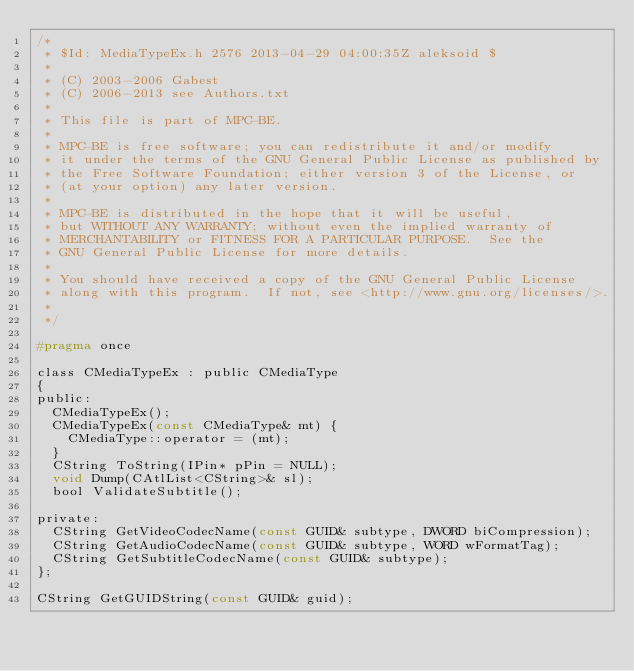<code> <loc_0><loc_0><loc_500><loc_500><_C_>/*
 * $Id: MediaTypeEx.h 2576 2013-04-29 04:00:35Z aleksoid $
 *
 * (C) 2003-2006 Gabest
 * (C) 2006-2013 see Authors.txt
 *
 * This file is part of MPC-BE.
 *
 * MPC-BE is free software; you can redistribute it and/or modify
 * it under the terms of the GNU General Public License as published by
 * the Free Software Foundation; either version 3 of the License, or
 * (at your option) any later version.
 *
 * MPC-BE is distributed in the hope that it will be useful,
 * but WITHOUT ANY WARRANTY; without even the implied warranty of
 * MERCHANTABILITY or FITNESS FOR A PARTICULAR PURPOSE.  See the
 * GNU General Public License for more details.
 *
 * You should have received a copy of the GNU General Public License
 * along with this program.  If not, see <http://www.gnu.org/licenses/>.
 *
 */

#pragma once

class CMediaTypeEx : public CMediaType
{
public:
	CMediaTypeEx();
	CMediaTypeEx(const CMediaType& mt) {
		CMediaType::operator = (mt);
	}
	CString ToString(IPin* pPin = NULL);
	void Dump(CAtlList<CString>& sl);
	bool ValidateSubtitle();

private:
	CString GetVideoCodecName(const GUID& subtype, DWORD biCompression);
	CString GetAudioCodecName(const GUID& subtype, WORD wFormatTag);
	CString GetSubtitleCodecName(const GUID& subtype);
};

CString GetGUIDString(const GUID& guid);
</code> 